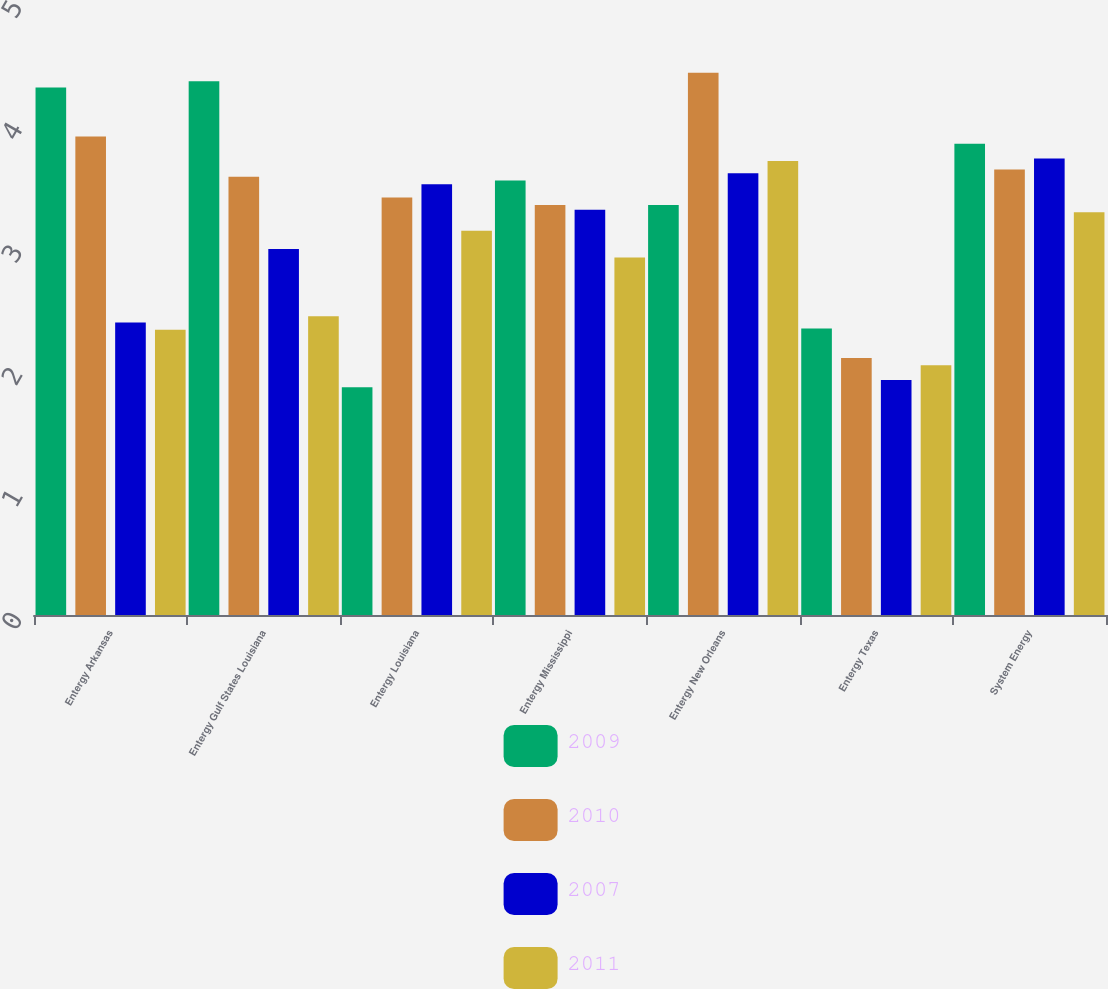Convert chart. <chart><loc_0><loc_0><loc_500><loc_500><stacked_bar_chart><ecel><fcel>Entergy Arkansas<fcel>Entergy Gulf States Louisiana<fcel>Entergy Louisiana<fcel>Entergy Mississippi<fcel>Entergy New Orleans<fcel>Entergy Texas<fcel>System Energy<nl><fcel>2009<fcel>4.31<fcel>4.36<fcel>1.86<fcel>3.55<fcel>3.35<fcel>2.34<fcel>3.85<nl><fcel>2010<fcel>3.91<fcel>3.58<fcel>3.41<fcel>3.35<fcel>4.43<fcel>2.1<fcel>3.64<nl><fcel>2007<fcel>2.39<fcel>2.99<fcel>3.52<fcel>3.31<fcel>3.61<fcel>1.92<fcel>3.73<nl><fcel>2011<fcel>2.33<fcel>2.44<fcel>3.14<fcel>2.92<fcel>3.71<fcel>2.04<fcel>3.29<nl></chart> 